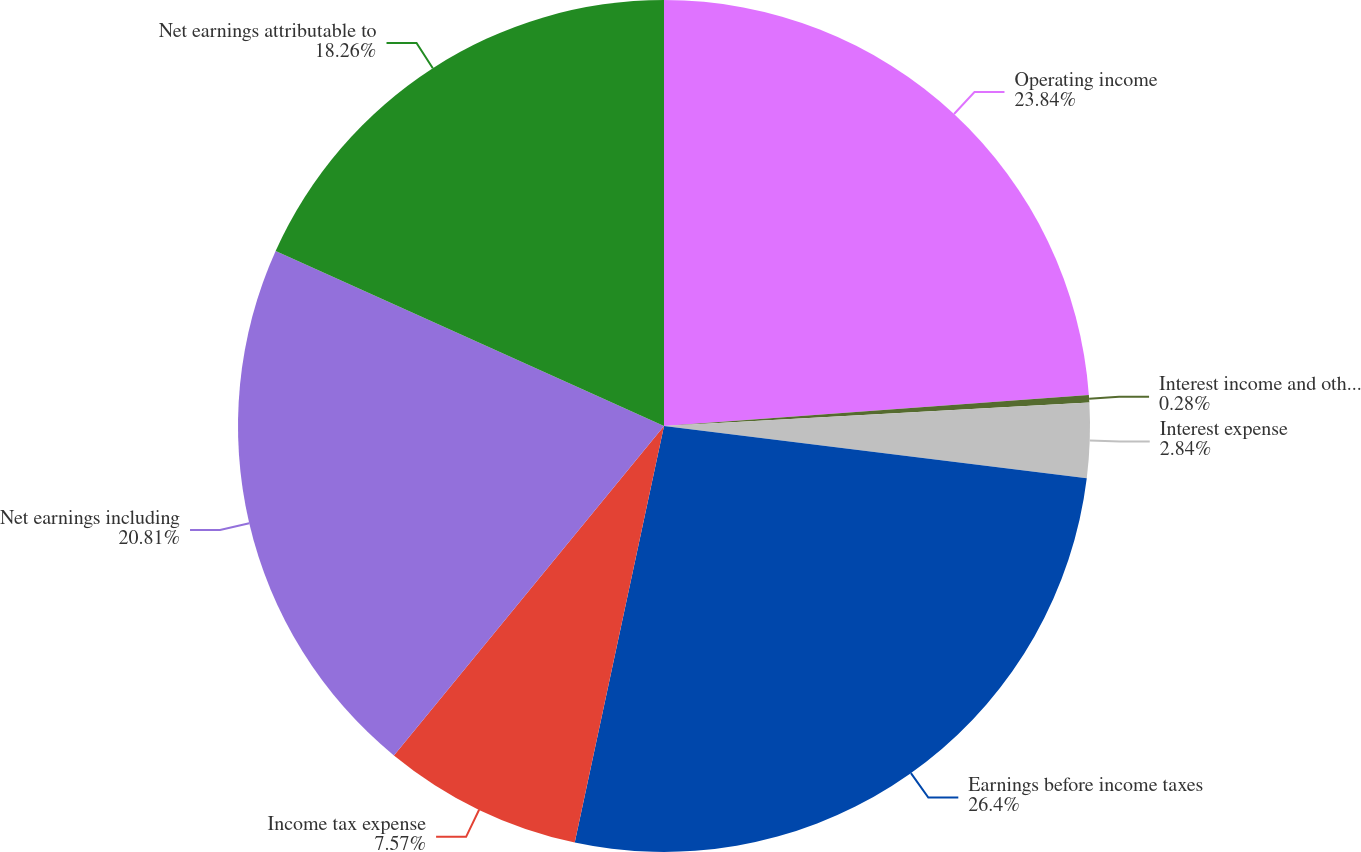Convert chart. <chart><loc_0><loc_0><loc_500><loc_500><pie_chart><fcel>Operating income<fcel>Interest income and other net<fcel>Interest expense<fcel>Earnings before income taxes<fcel>Income tax expense<fcel>Net earnings including<fcel>Net earnings attributable to<nl><fcel>23.84%<fcel>0.28%<fcel>2.84%<fcel>26.4%<fcel>7.57%<fcel>20.81%<fcel>18.26%<nl></chart> 